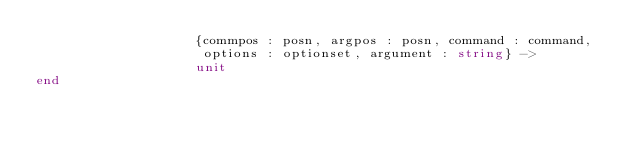<code> <loc_0><loc_0><loc_500><loc_500><_SML_>                    {commpos : posn, argpos : posn, command : command,
                     options : optionset, argument : string} ->
                    unit
end
</code> 